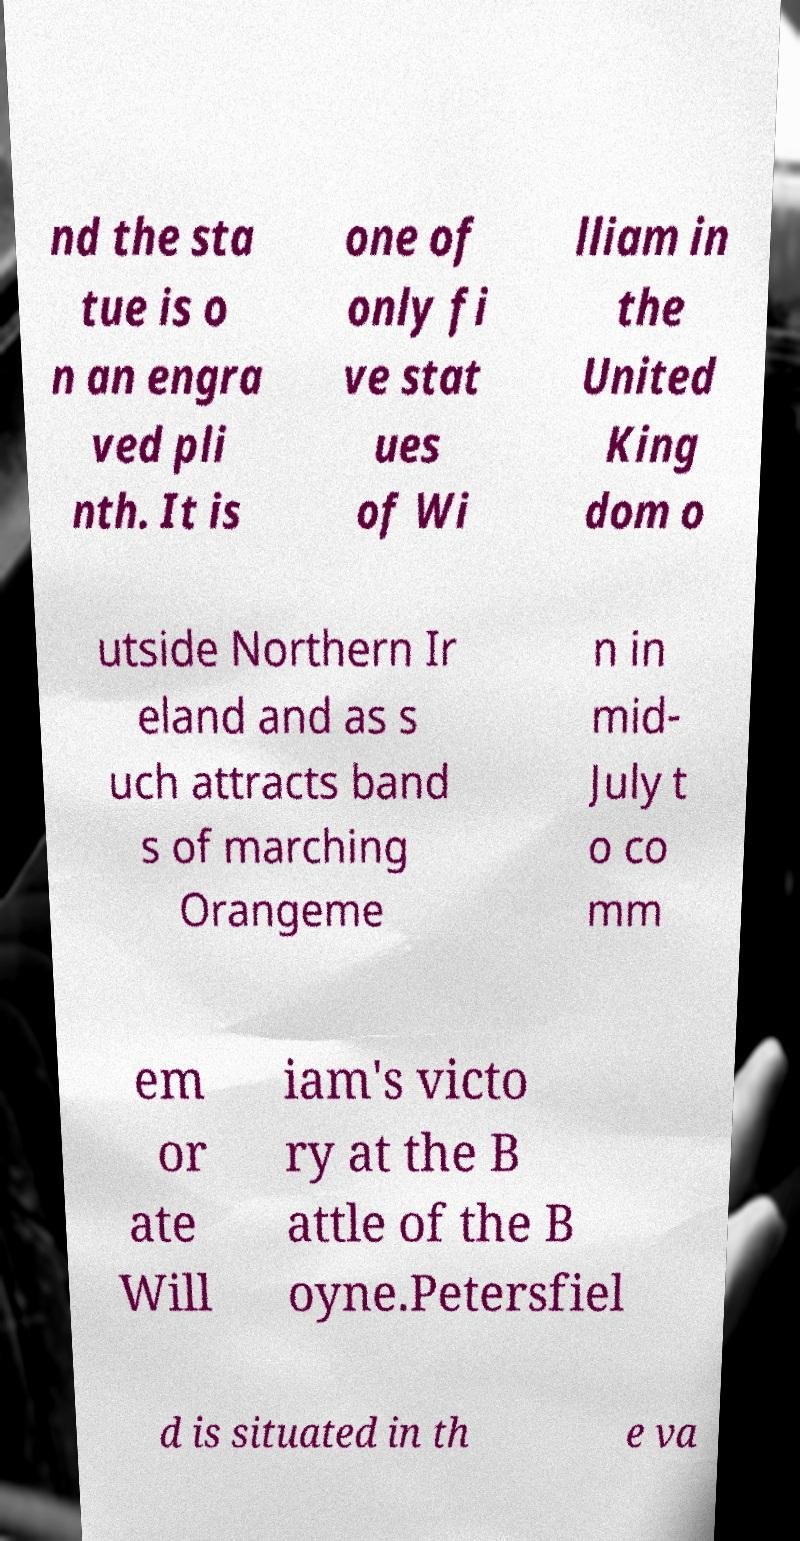Could you extract and type out the text from this image? nd the sta tue is o n an engra ved pli nth. It is one of only fi ve stat ues of Wi lliam in the United King dom o utside Northern Ir eland and as s uch attracts band s of marching Orangeme n in mid- July t o co mm em or ate Will iam's victo ry at the B attle of the B oyne.Petersfiel d is situated in th e va 